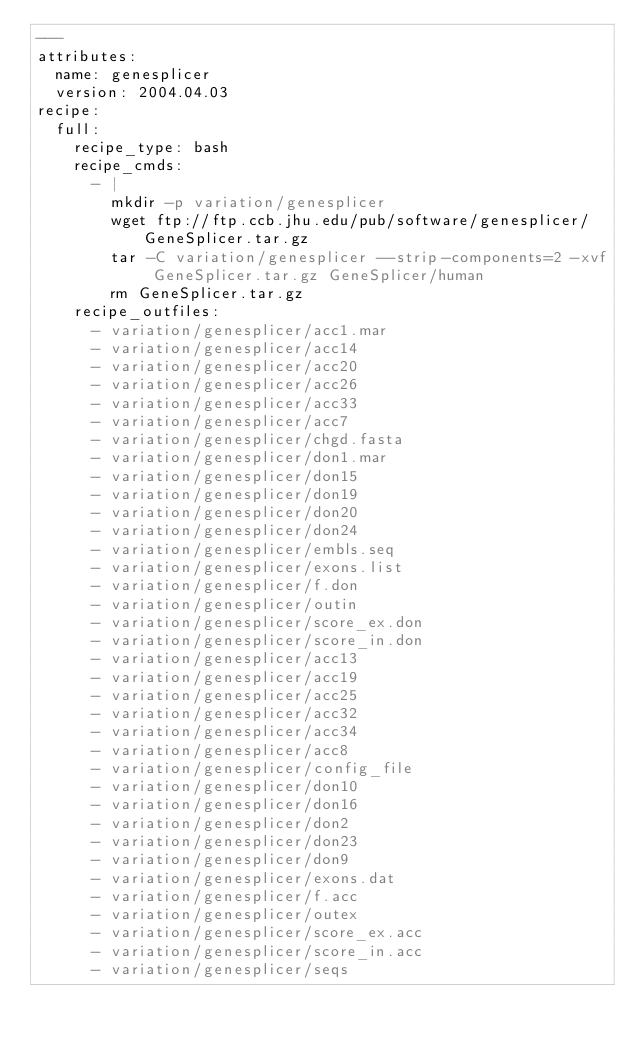Convert code to text. <code><loc_0><loc_0><loc_500><loc_500><_YAML_>---
attributes:
  name: genesplicer
  version: 2004.04.03
recipe:
  full:
    recipe_type: bash
    recipe_cmds:
      - |
        mkdir -p variation/genesplicer
        wget ftp://ftp.ccb.jhu.edu/pub/software/genesplicer/GeneSplicer.tar.gz
        tar -C variation/genesplicer --strip-components=2 -xvf GeneSplicer.tar.gz GeneSplicer/human
        rm GeneSplicer.tar.gz
    recipe_outfiles:
      - variation/genesplicer/acc1.mar
      - variation/genesplicer/acc14
      - variation/genesplicer/acc20
      - variation/genesplicer/acc26
      - variation/genesplicer/acc33
      - variation/genesplicer/acc7
      - variation/genesplicer/chgd.fasta
      - variation/genesplicer/don1.mar
      - variation/genesplicer/don15
      - variation/genesplicer/don19
      - variation/genesplicer/don20
      - variation/genesplicer/don24
      - variation/genesplicer/embls.seq
      - variation/genesplicer/exons.list
      - variation/genesplicer/f.don
      - variation/genesplicer/outin
      - variation/genesplicer/score_ex.don
      - variation/genesplicer/score_in.don
      - variation/genesplicer/acc13
      - variation/genesplicer/acc19
      - variation/genesplicer/acc25
      - variation/genesplicer/acc32
      - variation/genesplicer/acc34
      - variation/genesplicer/acc8
      - variation/genesplicer/config_file
      - variation/genesplicer/don10
      - variation/genesplicer/don16
      - variation/genesplicer/don2
      - variation/genesplicer/don23
      - variation/genesplicer/don9
      - variation/genesplicer/exons.dat
      - variation/genesplicer/f.acc
      - variation/genesplicer/outex
      - variation/genesplicer/score_ex.acc
      - variation/genesplicer/score_in.acc
      - variation/genesplicer/seqs
</code> 